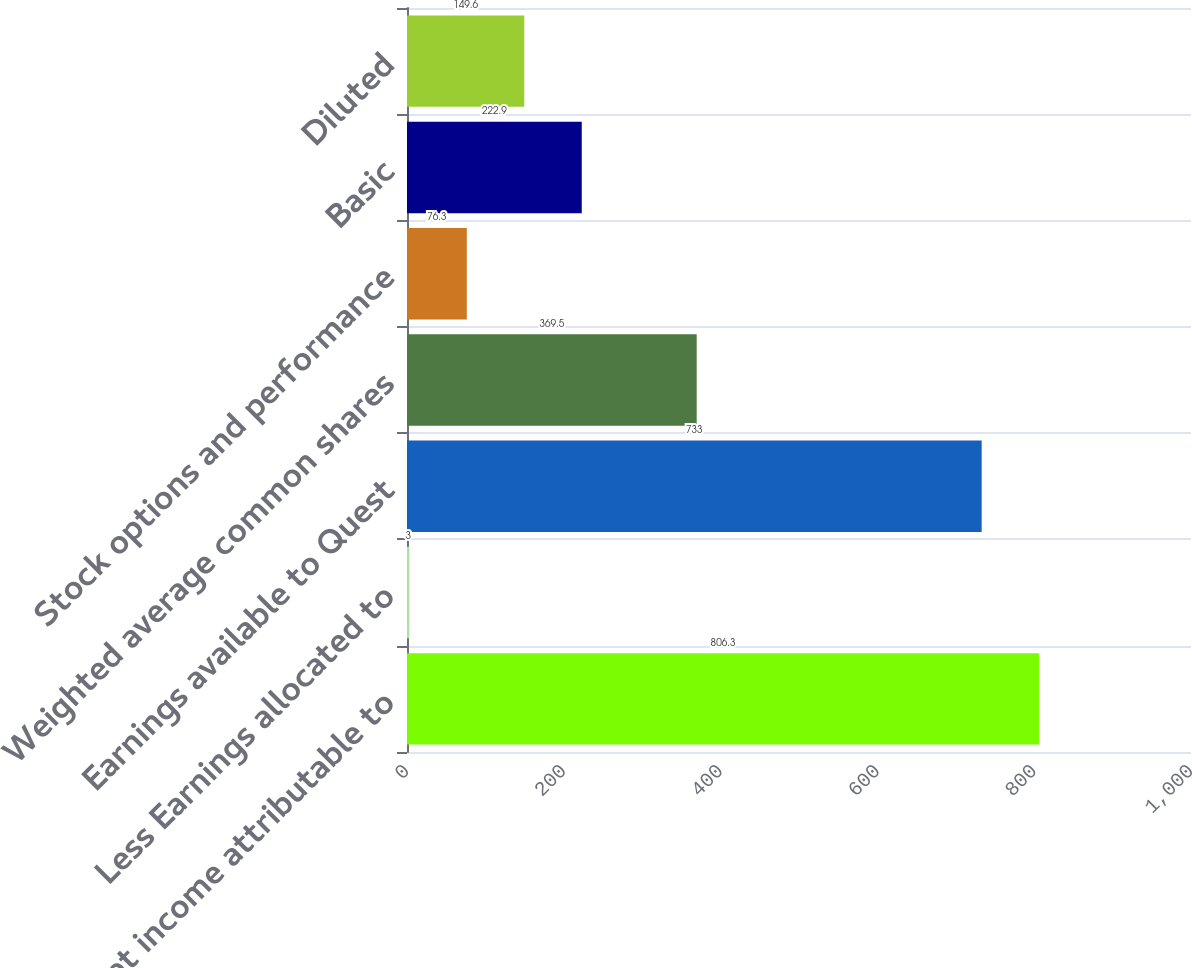Convert chart to OTSL. <chart><loc_0><loc_0><loc_500><loc_500><bar_chart><fcel>Net income attributable to<fcel>Less Earnings allocated to<fcel>Earnings available to Quest<fcel>Weighted average common shares<fcel>Stock options and performance<fcel>Basic<fcel>Diluted<nl><fcel>806.3<fcel>3<fcel>733<fcel>369.5<fcel>76.3<fcel>222.9<fcel>149.6<nl></chart> 